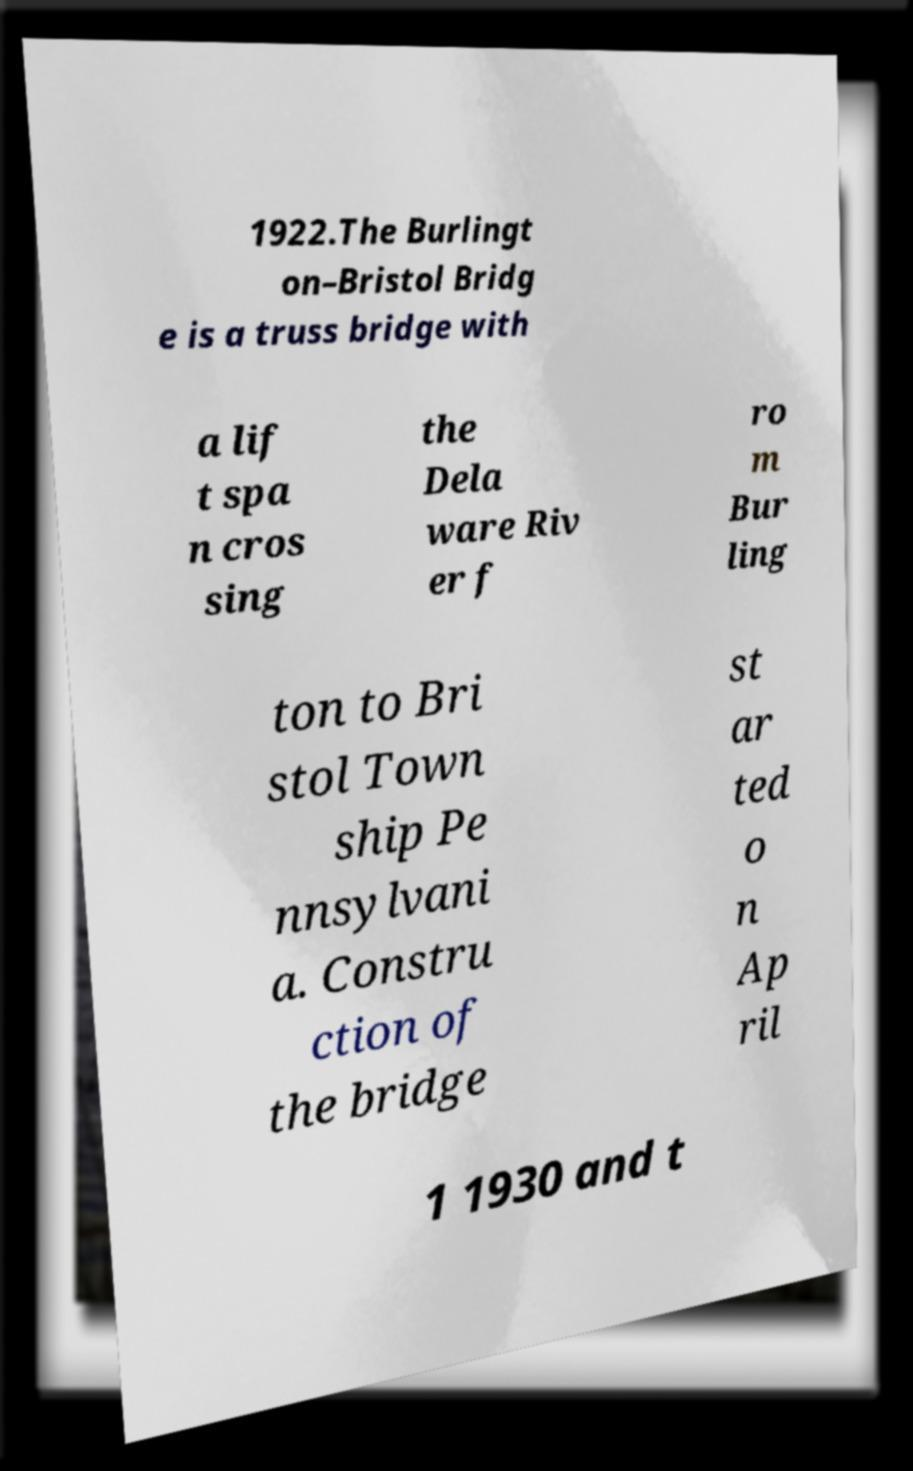Can you read and provide the text displayed in the image?This photo seems to have some interesting text. Can you extract and type it out for me? 1922.The Burlingt on–Bristol Bridg e is a truss bridge with a lif t spa n cros sing the Dela ware Riv er f ro m Bur ling ton to Bri stol Town ship Pe nnsylvani a. Constru ction of the bridge st ar ted o n Ap ril 1 1930 and t 